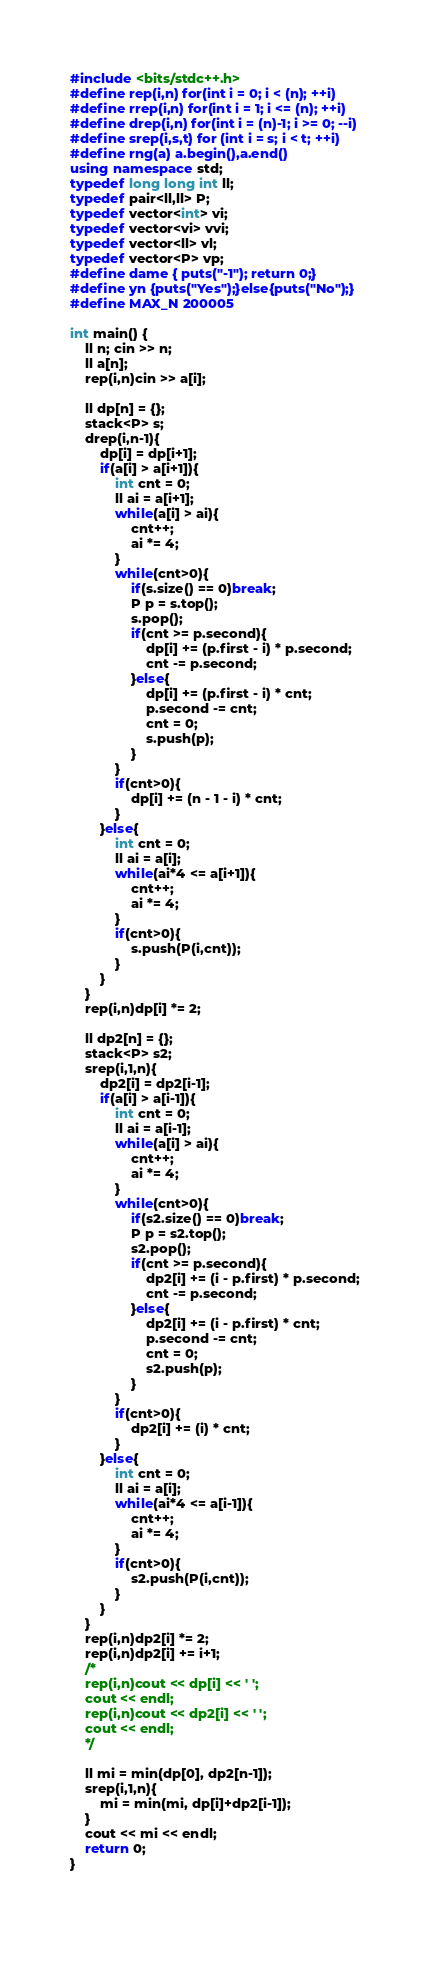<code> <loc_0><loc_0><loc_500><loc_500><_C++_>#include <bits/stdc++.h>
#define rep(i,n) for(int i = 0; i < (n); ++i)
#define rrep(i,n) for(int i = 1; i <= (n); ++i)
#define drep(i,n) for(int i = (n)-1; i >= 0; --i)
#define srep(i,s,t) for (int i = s; i < t; ++i)
#define rng(a) a.begin(),a.end()
using namespace std;
typedef long long int ll;
typedef pair<ll,ll> P;
typedef vector<int> vi;
typedef vector<vi> vvi;
typedef vector<ll> vl;
typedef vector<P> vp;
#define dame { puts("-1"); return 0;}
#define yn {puts("Yes");}else{puts("No");}
#define MAX_N 200005

int main() {
    ll n; cin >> n;
    ll a[n];
    rep(i,n)cin >> a[i];

    ll dp[n] = {};
    stack<P> s;
    drep(i,n-1){
        dp[i] = dp[i+1];
        if(a[i] > a[i+1]){
            int cnt = 0;
            ll ai = a[i+1];
            while(a[i] > ai){
                cnt++;
                ai *= 4;
            }
            while(cnt>0){
                if(s.size() == 0)break;
                P p = s.top();
                s.pop();
                if(cnt >= p.second){
                    dp[i] += (p.first - i) * p.second;
                    cnt -= p.second;
                }else{
                    dp[i] += (p.first - i) * cnt;
                    p.second -= cnt;
                    cnt = 0;
                    s.push(p);
                }
            }
            if(cnt>0){
                dp[i] += (n - 1 - i) * cnt;
            }
        }else{
            int cnt = 0;
            ll ai = a[i];
            while(ai*4 <= a[i+1]){
                cnt++;
                ai *= 4;
            }
            if(cnt>0){
                s.push(P(i,cnt));
            }
        }
    }
    rep(i,n)dp[i] *= 2;

    ll dp2[n] = {};
    stack<P> s2;
    srep(i,1,n){
        dp2[i] = dp2[i-1];
        if(a[i] > a[i-1]){
            int cnt = 0;
            ll ai = a[i-1];
            while(a[i] > ai){
                cnt++;
                ai *= 4;
            }
            while(cnt>0){
                if(s2.size() == 0)break;
                P p = s2.top();
                s2.pop();
                if(cnt >= p.second){
                    dp2[i] += (i - p.first) * p.second;
                    cnt -= p.second;
                }else{
                    dp2[i] += (i - p.first) * cnt;
                    p.second -= cnt;
                    cnt = 0;
                    s2.push(p);
                }
            }
            if(cnt>0){
                dp2[i] += (i) * cnt;
            }
        }else{
            int cnt = 0;
            ll ai = a[i];
            while(ai*4 <= a[i-1]){
                cnt++;
                ai *= 4;
            }
            if(cnt>0){
                s2.push(P(i,cnt));
            }
        }
    }
    rep(i,n)dp2[i] *= 2;
    rep(i,n)dp2[i] += i+1;
    /*
    rep(i,n)cout << dp[i] << ' ';
    cout << endl;
    rep(i,n)cout << dp2[i] << ' ';
    cout << endl;
    */

    ll mi = min(dp[0], dp2[n-1]);
    srep(i,1,n){
        mi = min(mi, dp[i]+dp2[i-1]);
    }
    cout << mi << endl;
    return 0;
}
 
 
</code> 